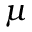Convert formula to latex. <formula><loc_0><loc_0><loc_500><loc_500>\mu</formula> 